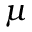Convert formula to latex. <formula><loc_0><loc_0><loc_500><loc_500>\mu</formula> 